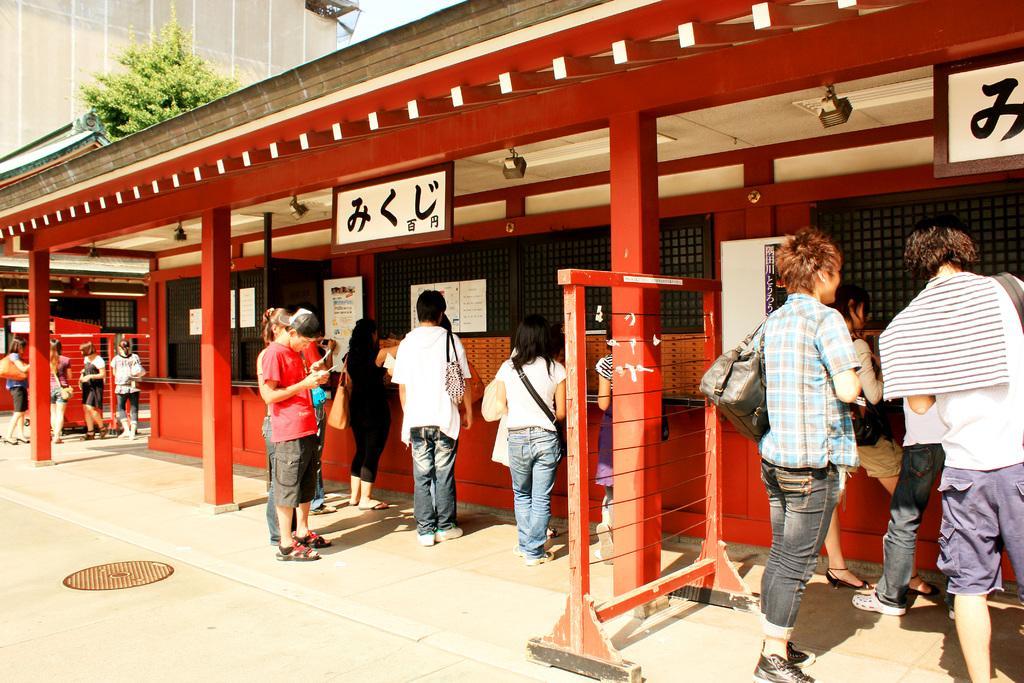Describe this image in one or two sentences. In this image I can see people standing. There is a building which has boards. There is a tree on the left. 